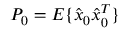Convert formula to latex. <formula><loc_0><loc_0><loc_500><loc_500>P _ { 0 } = E \{ \hat { x } _ { 0 } \hat { x } _ { 0 } ^ { T } \}</formula> 